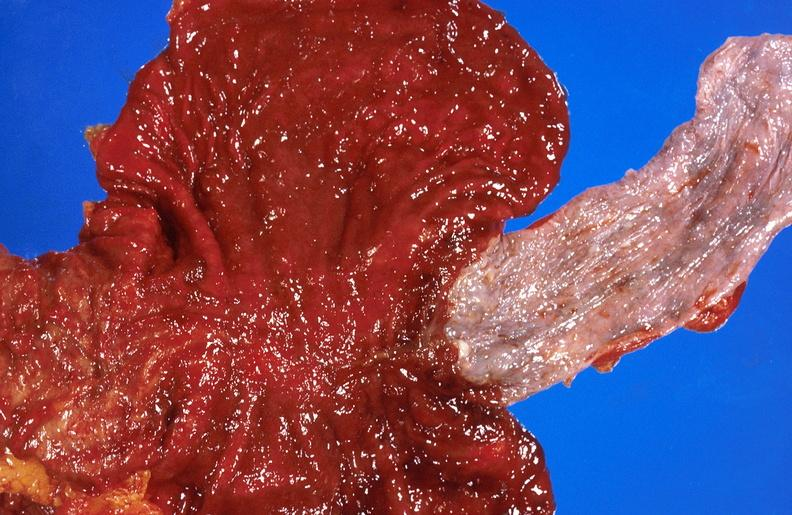what is present?
Answer the question using a single word or phrase. Hepatobiliary 